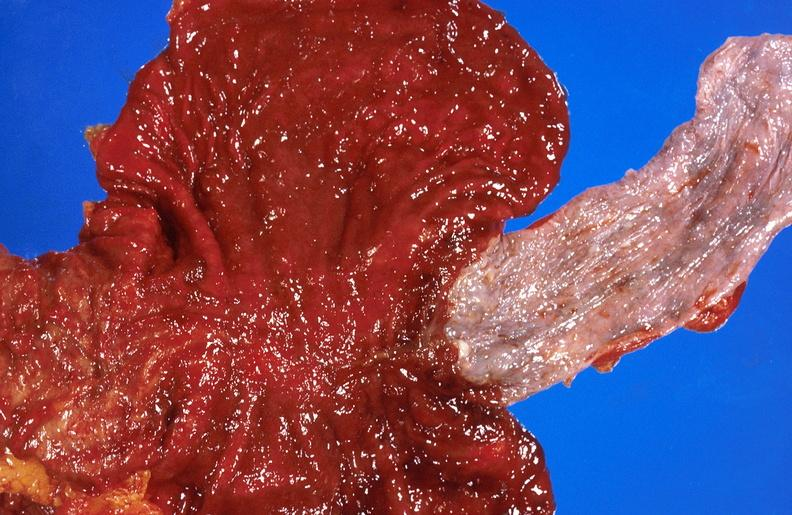what is present?
Answer the question using a single word or phrase. Hepatobiliary 